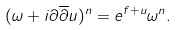<formula> <loc_0><loc_0><loc_500><loc_500>( \omega + i \partial \overline { \partial } u ) ^ { n } = e ^ { f + u } \omega ^ { n } .</formula> 